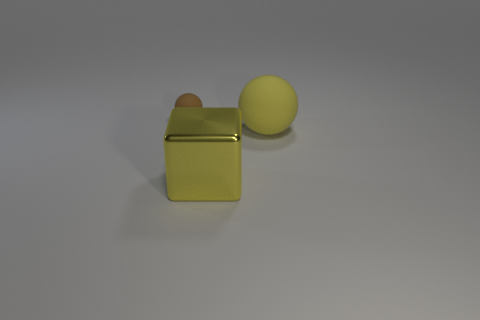Are there more big objects that are behind the metal block than small matte spheres in front of the tiny rubber object?
Offer a terse response. Yes. Is the number of big matte blocks greater than the number of large yellow rubber things?
Give a very brief answer. No. There is a object that is on the left side of the big matte thing and behind the large cube; what is its size?
Offer a very short reply. Small. What shape is the brown matte object?
Your response must be concise. Sphere. Is there anything else that is the same size as the brown matte ball?
Offer a very short reply. No. Are there more brown rubber objects behind the big yellow matte sphere than large blue balls?
Make the answer very short. Yes. What is the shape of the rubber object to the right of the matte object left of the ball in front of the small rubber ball?
Provide a short and direct response. Sphere. There is a rubber object that is on the right side of the cube; does it have the same size as the yellow shiny cube?
Give a very brief answer. Yes. The thing that is both right of the brown rubber object and behind the big cube has what shape?
Give a very brief answer. Sphere. There is a big matte thing; is it the same color as the big block in front of the brown rubber thing?
Provide a succinct answer. Yes. 